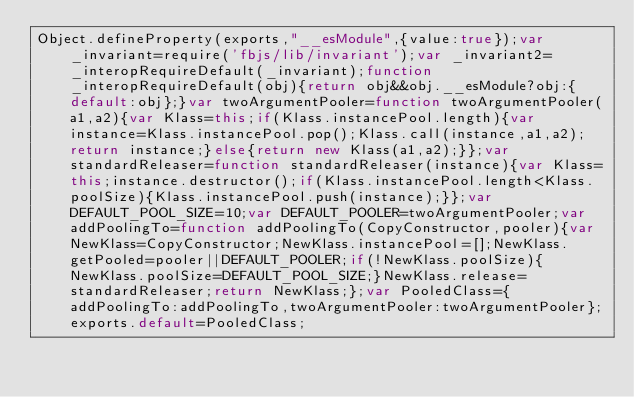Convert code to text. <code><loc_0><loc_0><loc_500><loc_500><_JavaScript_>Object.defineProperty(exports,"__esModule",{value:true});var _invariant=require('fbjs/lib/invariant');var _invariant2=_interopRequireDefault(_invariant);function _interopRequireDefault(obj){return obj&&obj.__esModule?obj:{default:obj};}var twoArgumentPooler=function twoArgumentPooler(a1,a2){var Klass=this;if(Klass.instancePool.length){var instance=Klass.instancePool.pop();Klass.call(instance,a1,a2);return instance;}else{return new Klass(a1,a2);}};var standardReleaser=function standardReleaser(instance){var Klass=this;instance.destructor();if(Klass.instancePool.length<Klass.poolSize){Klass.instancePool.push(instance);}};var DEFAULT_POOL_SIZE=10;var DEFAULT_POOLER=twoArgumentPooler;var addPoolingTo=function addPoolingTo(CopyConstructor,pooler){var NewKlass=CopyConstructor;NewKlass.instancePool=[];NewKlass.getPooled=pooler||DEFAULT_POOLER;if(!NewKlass.poolSize){NewKlass.poolSize=DEFAULT_POOL_SIZE;}NewKlass.release=standardReleaser;return NewKlass;};var PooledClass={addPoolingTo:addPoolingTo,twoArgumentPooler:twoArgumentPooler};exports.default=PooledClass;</code> 